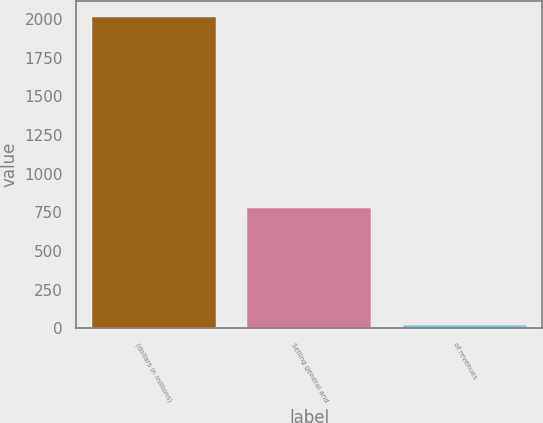Convert chart. <chart><loc_0><loc_0><loc_500><loc_500><bar_chart><fcel>(dollars in millions)<fcel>Selling general and<fcel>of revenues<nl><fcel>2014<fcel>781<fcel>18.8<nl></chart> 